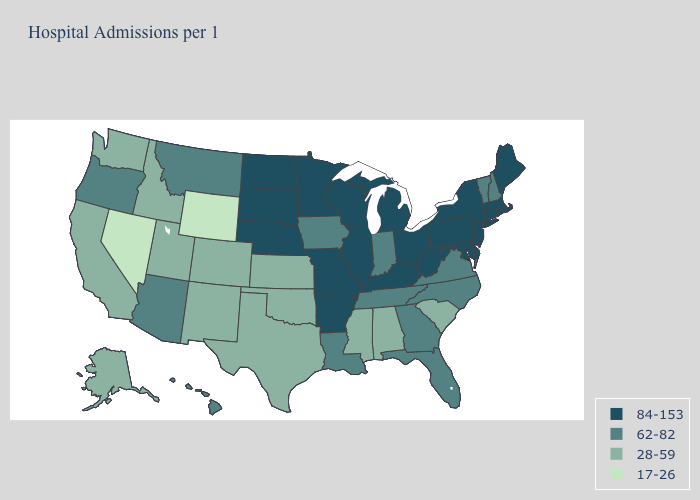What is the value of Hawaii?
Concise answer only. 62-82. Does Maryland have the lowest value in the USA?
Be succinct. No. What is the value of Illinois?
Give a very brief answer. 84-153. What is the lowest value in the West?
Give a very brief answer. 17-26. Among the states that border Arizona , does New Mexico have the lowest value?
Be succinct. No. Does West Virginia have the highest value in the South?
Answer briefly. Yes. Does the map have missing data?
Concise answer only. No. What is the highest value in the USA?
Answer briefly. 84-153. Among the states that border Indiana , which have the highest value?
Write a very short answer. Illinois, Kentucky, Michigan, Ohio. Does Mississippi have the same value as Alabama?
Quick response, please. Yes. Name the states that have a value in the range 62-82?
Short answer required. Arizona, Florida, Georgia, Hawaii, Indiana, Iowa, Louisiana, Montana, New Hampshire, North Carolina, Oregon, Tennessee, Vermont, Virginia. What is the value of West Virginia?
Give a very brief answer. 84-153. What is the highest value in the USA?
Be succinct. 84-153. Among the states that border Idaho , does Nevada have the highest value?
Keep it brief. No. Which states have the lowest value in the Northeast?
Write a very short answer. New Hampshire, Vermont. 